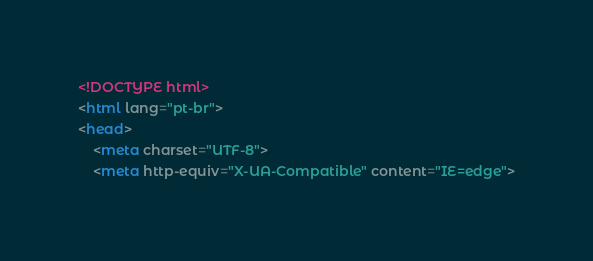<code> <loc_0><loc_0><loc_500><loc_500><_HTML_><!DOCTYPE html>
<html lang="pt-br">
<head>
    <meta charset="UTF-8">
    <meta http-equiv="X-UA-Compatible" content="IE=edge"></code> 